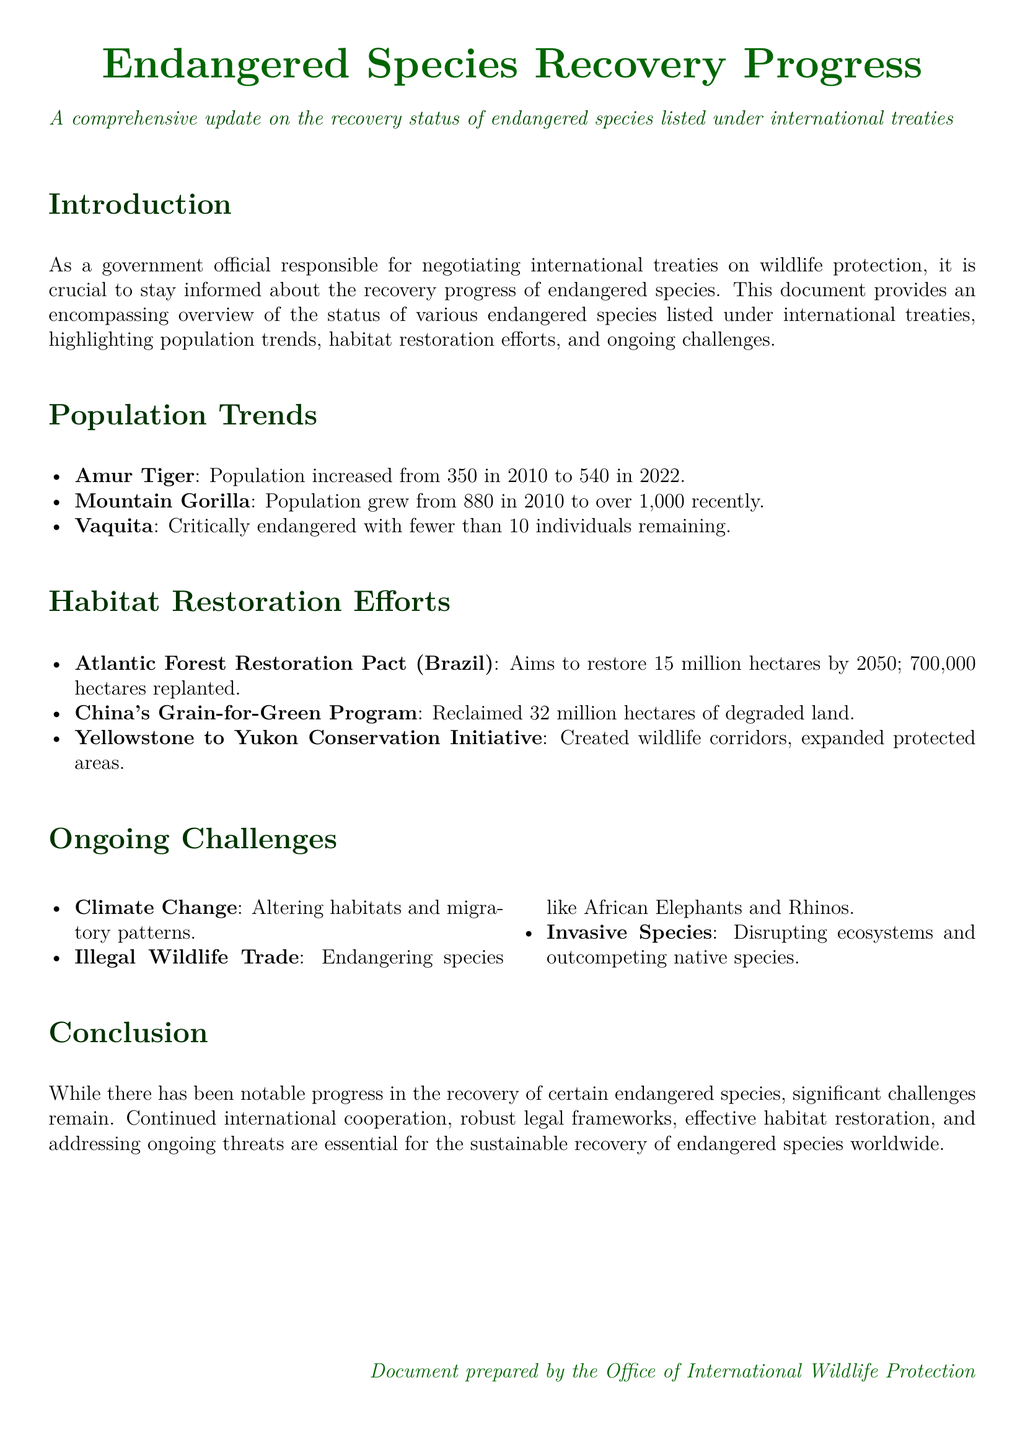What is the population of Amur Tigers in 2022? The document states that the population of Amur Tigers increased to 540 in 2022.
Answer: 540 How many hectares does the Atlantic Forest Restoration Pact aim to restore by 2050? The document mentions that this pact aims to restore 15 million hectares by 2050.
Answer: 15 million hectares What is the population trend of Mountain Gorillas since 2010? According to the document, the population of Mountain Gorillas grew from 880 in 2010 to over 1,000 recently.
Answer: Grew from 880 to over 1,000 How many individuals of Vaquita are remaining? The document reports that fewer than 10 individuals of Vaquita remain.
Answer: Fewer than 10 What are the main ongoing challenges listed in the document? The challenges include Climate Change, Illegal Wildlife Trade, and Invasive Species disrupting ecosystems.
Answer: Climate Change, Illegal Wildlife Trade, Invasive Species Which program has reclaimed 32 million hectares of degraded land? The document refers to China's Grain-for-Green Program as the initiative that reclaimed this amount of land.
Answer: China's Grain-for-Green Program What is the purpose of the Yellowstone to Yukon Conservation Initiative? The document indicates that its purpose is to create wildlife corridors and expand protected areas.
Answer: Create wildlife corridors, expand protected areas How many hectares have been replanted under the Atlantic Forest Restoration Pact? The document states that 700,000 hectares have been replanted under this initiative.
Answer: 700,000 hectares 